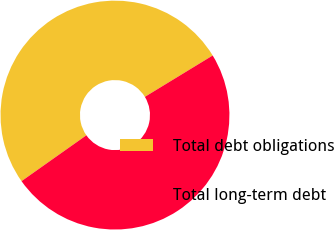Convert chart to OTSL. <chart><loc_0><loc_0><loc_500><loc_500><pie_chart><fcel>Total debt obligations<fcel>Total long-term debt<nl><fcel>51.08%<fcel>48.92%<nl></chart> 